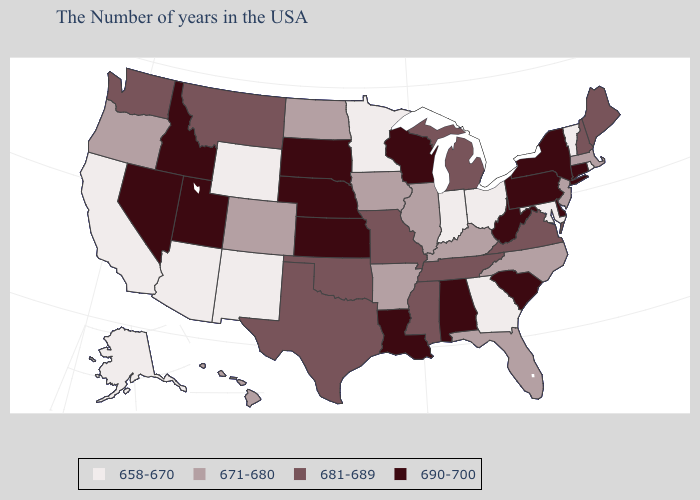Is the legend a continuous bar?
Be succinct. No. What is the value of Utah?
Concise answer only. 690-700. Name the states that have a value in the range 658-670?
Be succinct. Rhode Island, Vermont, Maryland, Ohio, Georgia, Indiana, Minnesota, Wyoming, New Mexico, Arizona, California, Alaska. Name the states that have a value in the range 690-700?
Give a very brief answer. Connecticut, New York, Delaware, Pennsylvania, South Carolina, West Virginia, Alabama, Wisconsin, Louisiana, Kansas, Nebraska, South Dakota, Utah, Idaho, Nevada. Which states have the highest value in the USA?
Short answer required. Connecticut, New York, Delaware, Pennsylvania, South Carolina, West Virginia, Alabama, Wisconsin, Louisiana, Kansas, Nebraska, South Dakota, Utah, Idaho, Nevada. Among the states that border Missouri , which have the lowest value?
Write a very short answer. Kentucky, Illinois, Arkansas, Iowa. Does Wyoming have a lower value than Mississippi?
Be succinct. Yes. Name the states that have a value in the range 658-670?
Concise answer only. Rhode Island, Vermont, Maryland, Ohio, Georgia, Indiana, Minnesota, Wyoming, New Mexico, Arizona, California, Alaska. What is the highest value in the MidWest ?
Short answer required. 690-700. How many symbols are there in the legend?
Short answer required. 4. What is the lowest value in states that border Kansas?
Give a very brief answer. 671-680. Name the states that have a value in the range 658-670?
Write a very short answer. Rhode Island, Vermont, Maryland, Ohio, Georgia, Indiana, Minnesota, Wyoming, New Mexico, Arizona, California, Alaska. Does Colorado have a lower value than Alaska?
Give a very brief answer. No. What is the value of Iowa?
Give a very brief answer. 671-680. Name the states that have a value in the range 671-680?
Be succinct. Massachusetts, New Jersey, North Carolina, Florida, Kentucky, Illinois, Arkansas, Iowa, North Dakota, Colorado, Oregon, Hawaii. 